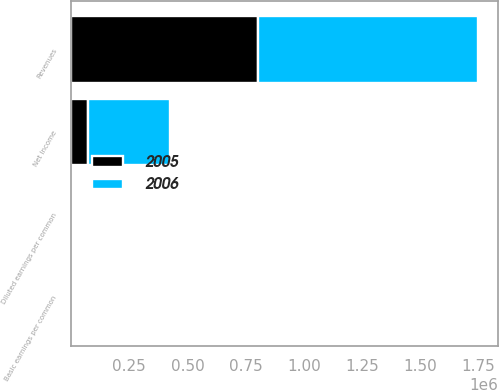<chart> <loc_0><loc_0><loc_500><loc_500><stacked_bar_chart><ecel><fcel>Revenues<fcel>Net Income<fcel>Basic earnings per common<fcel>Diluted earnings per common<nl><fcel>2006<fcel>943485<fcel>351239<fcel>1.95<fcel>1.94<nl><fcel>2005<fcel>801725<fcel>73364<fcel>0.32<fcel>0.32<nl></chart> 